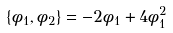Convert formula to latex. <formula><loc_0><loc_0><loc_500><loc_500>\{ \phi _ { 1 } , \phi _ { 2 } \} = - 2 \phi _ { 1 } + 4 \phi _ { 1 } ^ { 2 }</formula> 